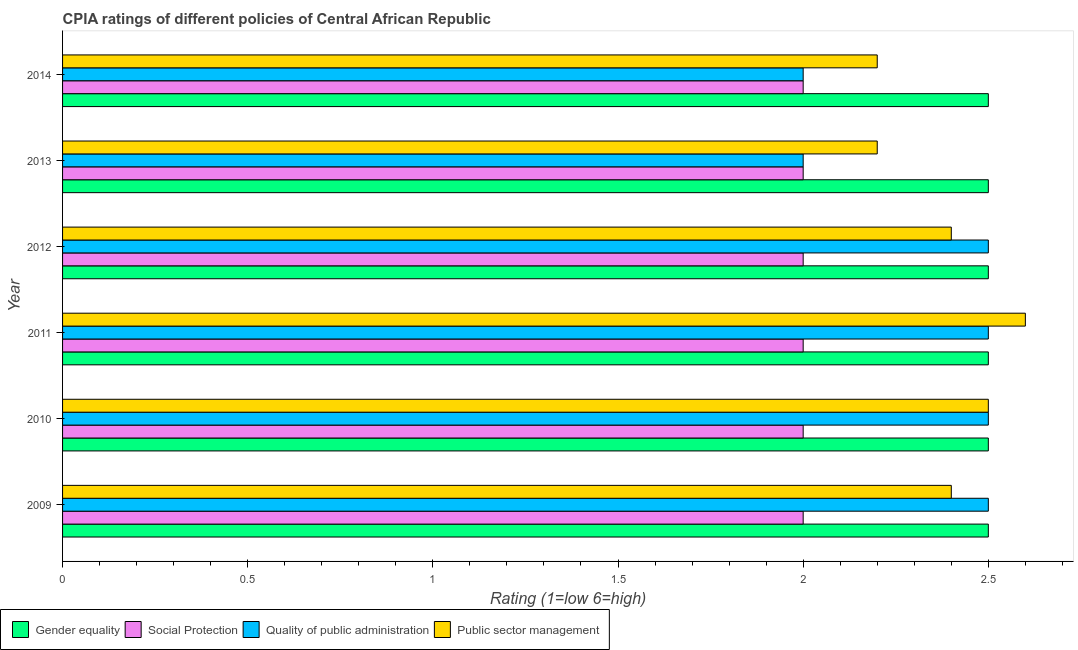Are the number of bars per tick equal to the number of legend labels?
Your answer should be compact. Yes. Are the number of bars on each tick of the Y-axis equal?
Your response must be concise. Yes. How many bars are there on the 3rd tick from the top?
Make the answer very short. 4. What is the label of the 4th group of bars from the top?
Your response must be concise. 2011. Across all years, what is the maximum cpia rating of social protection?
Make the answer very short. 2. In which year was the cpia rating of public sector management minimum?
Your response must be concise. 2013. What is the total cpia rating of social protection in the graph?
Your answer should be very brief. 12. What is the difference between the cpia rating of public sector management in 2013 and that in 2014?
Ensure brevity in your answer.  0. What is the average cpia rating of social protection per year?
Your response must be concise. 2. In the year 2009, what is the difference between the cpia rating of gender equality and cpia rating of quality of public administration?
Keep it short and to the point. 0. What is the ratio of the cpia rating of quality of public administration in 2009 to that in 2014?
Make the answer very short. 1.25. What is the difference between the highest and the second highest cpia rating of public sector management?
Offer a terse response. 0.1. What is the difference between the highest and the lowest cpia rating of gender equality?
Keep it short and to the point. 0. Is the sum of the cpia rating of social protection in 2009 and 2014 greater than the maximum cpia rating of gender equality across all years?
Make the answer very short. Yes. Is it the case that in every year, the sum of the cpia rating of social protection and cpia rating of quality of public administration is greater than the sum of cpia rating of public sector management and cpia rating of gender equality?
Offer a very short reply. No. What does the 3rd bar from the top in 2009 represents?
Give a very brief answer. Social Protection. What does the 2nd bar from the bottom in 2009 represents?
Offer a terse response. Social Protection. How many bars are there?
Keep it short and to the point. 24. Are all the bars in the graph horizontal?
Your answer should be compact. Yes. How many years are there in the graph?
Provide a short and direct response. 6. Are the values on the major ticks of X-axis written in scientific E-notation?
Offer a very short reply. No. Does the graph contain any zero values?
Make the answer very short. No. Does the graph contain grids?
Your answer should be very brief. No. What is the title of the graph?
Your answer should be very brief. CPIA ratings of different policies of Central African Republic. Does "Quality of public administration" appear as one of the legend labels in the graph?
Offer a very short reply. Yes. What is the Rating (1=low 6=high) of Gender equality in 2009?
Give a very brief answer. 2.5. What is the Rating (1=low 6=high) of Social Protection in 2009?
Your answer should be very brief. 2. What is the Rating (1=low 6=high) of Quality of public administration in 2009?
Make the answer very short. 2.5. What is the Rating (1=low 6=high) in Public sector management in 2009?
Provide a short and direct response. 2.4. What is the Rating (1=low 6=high) in Gender equality in 2010?
Offer a very short reply. 2.5. What is the Rating (1=low 6=high) of Social Protection in 2010?
Give a very brief answer. 2. What is the Rating (1=low 6=high) of Gender equality in 2011?
Make the answer very short. 2.5. What is the Rating (1=low 6=high) of Quality of public administration in 2011?
Give a very brief answer. 2.5. What is the Rating (1=low 6=high) in Public sector management in 2011?
Ensure brevity in your answer.  2.6. What is the Rating (1=low 6=high) of Social Protection in 2012?
Give a very brief answer. 2. What is the Rating (1=low 6=high) in Quality of public administration in 2012?
Your answer should be compact. 2.5. What is the Rating (1=low 6=high) in Gender equality in 2013?
Give a very brief answer. 2.5. What is the Rating (1=low 6=high) in Social Protection in 2013?
Your answer should be very brief. 2. What is the Rating (1=low 6=high) in Quality of public administration in 2013?
Give a very brief answer. 2. What is the Rating (1=low 6=high) in Social Protection in 2014?
Your answer should be compact. 2. Across all years, what is the minimum Rating (1=low 6=high) of Social Protection?
Offer a very short reply. 2. What is the total Rating (1=low 6=high) of Gender equality in the graph?
Offer a very short reply. 15. What is the total Rating (1=low 6=high) of Social Protection in the graph?
Offer a very short reply. 12. What is the total Rating (1=low 6=high) of Quality of public administration in the graph?
Keep it short and to the point. 14. What is the total Rating (1=low 6=high) in Public sector management in the graph?
Ensure brevity in your answer.  14.3. What is the difference between the Rating (1=low 6=high) of Gender equality in 2009 and that in 2010?
Your response must be concise. 0. What is the difference between the Rating (1=low 6=high) in Public sector management in 2009 and that in 2010?
Offer a terse response. -0.1. What is the difference between the Rating (1=low 6=high) of Social Protection in 2009 and that in 2011?
Ensure brevity in your answer.  0. What is the difference between the Rating (1=low 6=high) in Public sector management in 2009 and that in 2011?
Offer a very short reply. -0.2. What is the difference between the Rating (1=low 6=high) in Gender equality in 2009 and that in 2012?
Make the answer very short. 0. What is the difference between the Rating (1=low 6=high) in Social Protection in 2009 and that in 2012?
Your answer should be very brief. 0. What is the difference between the Rating (1=low 6=high) of Quality of public administration in 2009 and that in 2012?
Your answer should be compact. 0. What is the difference between the Rating (1=low 6=high) in Public sector management in 2009 and that in 2012?
Your answer should be compact. 0. What is the difference between the Rating (1=low 6=high) in Social Protection in 2009 and that in 2013?
Your answer should be very brief. 0. What is the difference between the Rating (1=low 6=high) of Quality of public administration in 2009 and that in 2013?
Keep it short and to the point. 0.5. What is the difference between the Rating (1=low 6=high) of Quality of public administration in 2009 and that in 2014?
Your response must be concise. 0.5. What is the difference between the Rating (1=low 6=high) in Gender equality in 2010 and that in 2011?
Offer a terse response. 0. What is the difference between the Rating (1=low 6=high) in Social Protection in 2010 and that in 2011?
Your response must be concise. 0. What is the difference between the Rating (1=low 6=high) of Public sector management in 2010 and that in 2011?
Give a very brief answer. -0.1. What is the difference between the Rating (1=low 6=high) in Gender equality in 2010 and that in 2013?
Your response must be concise. 0. What is the difference between the Rating (1=low 6=high) of Social Protection in 2010 and that in 2013?
Your answer should be very brief. 0. What is the difference between the Rating (1=low 6=high) of Gender equality in 2010 and that in 2014?
Your response must be concise. 0. What is the difference between the Rating (1=low 6=high) of Public sector management in 2010 and that in 2014?
Your response must be concise. 0.3. What is the difference between the Rating (1=low 6=high) in Social Protection in 2011 and that in 2012?
Your answer should be very brief. 0. What is the difference between the Rating (1=low 6=high) in Gender equality in 2011 and that in 2013?
Your answer should be compact. 0. What is the difference between the Rating (1=low 6=high) in Quality of public administration in 2011 and that in 2013?
Make the answer very short. 0.5. What is the difference between the Rating (1=low 6=high) of Public sector management in 2011 and that in 2013?
Provide a short and direct response. 0.4. What is the difference between the Rating (1=low 6=high) in Gender equality in 2011 and that in 2014?
Provide a short and direct response. 0. What is the difference between the Rating (1=low 6=high) of Social Protection in 2011 and that in 2014?
Keep it short and to the point. 0. What is the difference between the Rating (1=low 6=high) of Quality of public administration in 2011 and that in 2014?
Your answer should be very brief. 0.5. What is the difference between the Rating (1=low 6=high) of Gender equality in 2012 and that in 2013?
Your answer should be very brief. 0. What is the difference between the Rating (1=low 6=high) in Quality of public administration in 2012 and that in 2013?
Give a very brief answer. 0.5. What is the difference between the Rating (1=low 6=high) of Social Protection in 2012 and that in 2014?
Provide a succinct answer. 0. What is the difference between the Rating (1=low 6=high) of Quality of public administration in 2012 and that in 2014?
Ensure brevity in your answer.  0.5. What is the difference between the Rating (1=low 6=high) of Gender equality in 2013 and that in 2014?
Ensure brevity in your answer.  0. What is the difference between the Rating (1=low 6=high) in Quality of public administration in 2013 and that in 2014?
Provide a short and direct response. 0. What is the difference between the Rating (1=low 6=high) in Public sector management in 2013 and that in 2014?
Provide a short and direct response. 0. What is the difference between the Rating (1=low 6=high) of Gender equality in 2009 and the Rating (1=low 6=high) of Social Protection in 2010?
Provide a succinct answer. 0.5. What is the difference between the Rating (1=low 6=high) in Gender equality in 2009 and the Rating (1=low 6=high) in Quality of public administration in 2010?
Make the answer very short. 0. What is the difference between the Rating (1=low 6=high) of Gender equality in 2009 and the Rating (1=low 6=high) of Public sector management in 2010?
Offer a terse response. 0. What is the difference between the Rating (1=low 6=high) of Gender equality in 2009 and the Rating (1=low 6=high) of Quality of public administration in 2011?
Keep it short and to the point. 0. What is the difference between the Rating (1=low 6=high) in Social Protection in 2009 and the Rating (1=low 6=high) in Public sector management in 2011?
Keep it short and to the point. -0.6. What is the difference between the Rating (1=low 6=high) of Quality of public administration in 2009 and the Rating (1=low 6=high) of Public sector management in 2011?
Make the answer very short. -0.1. What is the difference between the Rating (1=low 6=high) in Social Protection in 2009 and the Rating (1=low 6=high) in Public sector management in 2012?
Offer a very short reply. -0.4. What is the difference between the Rating (1=low 6=high) in Gender equality in 2009 and the Rating (1=low 6=high) in Quality of public administration in 2013?
Keep it short and to the point. 0.5. What is the difference between the Rating (1=low 6=high) in Gender equality in 2009 and the Rating (1=low 6=high) in Public sector management in 2013?
Offer a very short reply. 0.3. What is the difference between the Rating (1=low 6=high) in Gender equality in 2009 and the Rating (1=low 6=high) in Quality of public administration in 2014?
Your response must be concise. 0.5. What is the difference between the Rating (1=low 6=high) in Gender equality in 2010 and the Rating (1=low 6=high) in Public sector management in 2011?
Ensure brevity in your answer.  -0.1. What is the difference between the Rating (1=low 6=high) in Social Protection in 2010 and the Rating (1=low 6=high) in Quality of public administration in 2011?
Your response must be concise. -0.5. What is the difference between the Rating (1=low 6=high) of Social Protection in 2010 and the Rating (1=low 6=high) of Public sector management in 2011?
Your response must be concise. -0.6. What is the difference between the Rating (1=low 6=high) in Quality of public administration in 2010 and the Rating (1=low 6=high) in Public sector management in 2011?
Your answer should be very brief. -0.1. What is the difference between the Rating (1=low 6=high) of Social Protection in 2010 and the Rating (1=low 6=high) of Quality of public administration in 2012?
Your answer should be compact. -0.5. What is the difference between the Rating (1=low 6=high) in Quality of public administration in 2010 and the Rating (1=low 6=high) in Public sector management in 2012?
Make the answer very short. 0.1. What is the difference between the Rating (1=low 6=high) in Gender equality in 2010 and the Rating (1=low 6=high) in Public sector management in 2013?
Provide a succinct answer. 0.3. What is the difference between the Rating (1=low 6=high) in Quality of public administration in 2010 and the Rating (1=low 6=high) in Public sector management in 2013?
Offer a terse response. 0.3. What is the difference between the Rating (1=low 6=high) of Social Protection in 2010 and the Rating (1=low 6=high) of Public sector management in 2014?
Offer a very short reply. -0.2. What is the difference between the Rating (1=low 6=high) of Gender equality in 2011 and the Rating (1=low 6=high) of Quality of public administration in 2012?
Your answer should be compact. 0. What is the difference between the Rating (1=low 6=high) in Gender equality in 2011 and the Rating (1=low 6=high) in Public sector management in 2012?
Keep it short and to the point. 0.1. What is the difference between the Rating (1=low 6=high) in Social Protection in 2011 and the Rating (1=low 6=high) in Quality of public administration in 2012?
Your answer should be very brief. -0.5. What is the difference between the Rating (1=low 6=high) in Social Protection in 2011 and the Rating (1=low 6=high) in Public sector management in 2012?
Provide a succinct answer. -0.4. What is the difference between the Rating (1=low 6=high) of Gender equality in 2011 and the Rating (1=low 6=high) of Quality of public administration in 2013?
Offer a terse response. 0.5. What is the difference between the Rating (1=low 6=high) of Gender equality in 2011 and the Rating (1=low 6=high) of Public sector management in 2013?
Make the answer very short. 0.3. What is the difference between the Rating (1=low 6=high) of Social Protection in 2011 and the Rating (1=low 6=high) of Public sector management in 2013?
Your response must be concise. -0.2. What is the difference between the Rating (1=low 6=high) in Social Protection in 2011 and the Rating (1=low 6=high) in Quality of public administration in 2014?
Provide a succinct answer. 0. What is the difference between the Rating (1=low 6=high) in Social Protection in 2011 and the Rating (1=low 6=high) in Public sector management in 2014?
Keep it short and to the point. -0.2. What is the difference between the Rating (1=low 6=high) of Gender equality in 2012 and the Rating (1=low 6=high) of Quality of public administration in 2013?
Provide a short and direct response. 0.5. What is the difference between the Rating (1=low 6=high) of Gender equality in 2012 and the Rating (1=low 6=high) of Public sector management in 2013?
Provide a succinct answer. 0.3. What is the difference between the Rating (1=low 6=high) in Social Protection in 2012 and the Rating (1=low 6=high) in Quality of public administration in 2013?
Ensure brevity in your answer.  0. What is the difference between the Rating (1=low 6=high) of Quality of public administration in 2012 and the Rating (1=low 6=high) of Public sector management in 2013?
Offer a very short reply. 0.3. What is the difference between the Rating (1=low 6=high) in Gender equality in 2012 and the Rating (1=low 6=high) in Quality of public administration in 2014?
Provide a succinct answer. 0.5. What is the difference between the Rating (1=low 6=high) of Gender equality in 2012 and the Rating (1=low 6=high) of Public sector management in 2014?
Provide a succinct answer. 0.3. What is the difference between the Rating (1=low 6=high) in Social Protection in 2012 and the Rating (1=low 6=high) in Public sector management in 2014?
Your response must be concise. -0.2. What is the difference between the Rating (1=low 6=high) of Quality of public administration in 2012 and the Rating (1=low 6=high) of Public sector management in 2014?
Your response must be concise. 0.3. What is the difference between the Rating (1=low 6=high) of Gender equality in 2013 and the Rating (1=low 6=high) of Quality of public administration in 2014?
Ensure brevity in your answer.  0.5. What is the difference between the Rating (1=low 6=high) of Social Protection in 2013 and the Rating (1=low 6=high) of Quality of public administration in 2014?
Your response must be concise. 0. What is the average Rating (1=low 6=high) in Gender equality per year?
Provide a succinct answer. 2.5. What is the average Rating (1=low 6=high) of Social Protection per year?
Your answer should be very brief. 2. What is the average Rating (1=low 6=high) in Quality of public administration per year?
Provide a succinct answer. 2.33. What is the average Rating (1=low 6=high) of Public sector management per year?
Offer a very short reply. 2.38. In the year 2009, what is the difference between the Rating (1=low 6=high) in Gender equality and Rating (1=low 6=high) in Social Protection?
Provide a succinct answer. 0.5. In the year 2009, what is the difference between the Rating (1=low 6=high) of Gender equality and Rating (1=low 6=high) of Quality of public administration?
Your answer should be very brief. 0. In the year 2009, what is the difference between the Rating (1=low 6=high) in Social Protection and Rating (1=low 6=high) in Quality of public administration?
Provide a succinct answer. -0.5. In the year 2010, what is the difference between the Rating (1=low 6=high) of Gender equality and Rating (1=low 6=high) of Public sector management?
Your answer should be very brief. 0. In the year 2010, what is the difference between the Rating (1=low 6=high) of Social Protection and Rating (1=low 6=high) of Quality of public administration?
Provide a short and direct response. -0.5. In the year 2010, what is the difference between the Rating (1=low 6=high) of Quality of public administration and Rating (1=low 6=high) of Public sector management?
Ensure brevity in your answer.  0. In the year 2011, what is the difference between the Rating (1=low 6=high) of Gender equality and Rating (1=low 6=high) of Social Protection?
Make the answer very short. 0.5. In the year 2011, what is the difference between the Rating (1=low 6=high) in Gender equality and Rating (1=low 6=high) in Public sector management?
Your answer should be compact. -0.1. In the year 2011, what is the difference between the Rating (1=low 6=high) of Quality of public administration and Rating (1=low 6=high) of Public sector management?
Give a very brief answer. -0.1. In the year 2012, what is the difference between the Rating (1=low 6=high) in Gender equality and Rating (1=low 6=high) in Social Protection?
Provide a succinct answer. 0.5. In the year 2012, what is the difference between the Rating (1=low 6=high) in Gender equality and Rating (1=low 6=high) in Quality of public administration?
Give a very brief answer. 0. In the year 2012, what is the difference between the Rating (1=low 6=high) in Social Protection and Rating (1=low 6=high) in Quality of public administration?
Offer a terse response. -0.5. In the year 2012, what is the difference between the Rating (1=low 6=high) of Social Protection and Rating (1=low 6=high) of Public sector management?
Your response must be concise. -0.4. In the year 2013, what is the difference between the Rating (1=low 6=high) in Gender equality and Rating (1=low 6=high) in Quality of public administration?
Provide a succinct answer. 0.5. In the year 2013, what is the difference between the Rating (1=low 6=high) in Gender equality and Rating (1=low 6=high) in Public sector management?
Keep it short and to the point. 0.3. In the year 2013, what is the difference between the Rating (1=low 6=high) in Social Protection and Rating (1=low 6=high) in Quality of public administration?
Give a very brief answer. 0. In the year 2014, what is the difference between the Rating (1=low 6=high) in Gender equality and Rating (1=low 6=high) in Social Protection?
Make the answer very short. 0.5. In the year 2014, what is the difference between the Rating (1=low 6=high) in Quality of public administration and Rating (1=low 6=high) in Public sector management?
Your response must be concise. -0.2. What is the ratio of the Rating (1=low 6=high) in Public sector management in 2009 to that in 2010?
Give a very brief answer. 0.96. What is the ratio of the Rating (1=low 6=high) in Gender equality in 2009 to that in 2011?
Provide a succinct answer. 1. What is the ratio of the Rating (1=low 6=high) of Social Protection in 2009 to that in 2011?
Your response must be concise. 1. What is the ratio of the Rating (1=low 6=high) of Quality of public administration in 2009 to that in 2011?
Give a very brief answer. 1. What is the ratio of the Rating (1=low 6=high) in Social Protection in 2009 to that in 2012?
Ensure brevity in your answer.  1. What is the ratio of the Rating (1=low 6=high) of Quality of public administration in 2009 to that in 2012?
Your response must be concise. 1. What is the ratio of the Rating (1=low 6=high) of Gender equality in 2009 to that in 2013?
Keep it short and to the point. 1. What is the ratio of the Rating (1=low 6=high) in Quality of public administration in 2009 to that in 2013?
Make the answer very short. 1.25. What is the ratio of the Rating (1=low 6=high) of Social Protection in 2009 to that in 2014?
Provide a succinct answer. 1. What is the ratio of the Rating (1=low 6=high) of Quality of public administration in 2009 to that in 2014?
Make the answer very short. 1.25. What is the ratio of the Rating (1=low 6=high) in Gender equality in 2010 to that in 2011?
Offer a very short reply. 1. What is the ratio of the Rating (1=low 6=high) in Social Protection in 2010 to that in 2011?
Your answer should be compact. 1. What is the ratio of the Rating (1=low 6=high) of Public sector management in 2010 to that in 2011?
Provide a succinct answer. 0.96. What is the ratio of the Rating (1=low 6=high) of Gender equality in 2010 to that in 2012?
Keep it short and to the point. 1. What is the ratio of the Rating (1=low 6=high) of Social Protection in 2010 to that in 2012?
Offer a very short reply. 1. What is the ratio of the Rating (1=low 6=high) of Public sector management in 2010 to that in 2012?
Offer a terse response. 1.04. What is the ratio of the Rating (1=low 6=high) in Gender equality in 2010 to that in 2013?
Give a very brief answer. 1. What is the ratio of the Rating (1=low 6=high) of Social Protection in 2010 to that in 2013?
Make the answer very short. 1. What is the ratio of the Rating (1=low 6=high) in Quality of public administration in 2010 to that in 2013?
Offer a terse response. 1.25. What is the ratio of the Rating (1=low 6=high) of Public sector management in 2010 to that in 2013?
Ensure brevity in your answer.  1.14. What is the ratio of the Rating (1=low 6=high) in Gender equality in 2010 to that in 2014?
Provide a succinct answer. 1. What is the ratio of the Rating (1=low 6=high) of Quality of public administration in 2010 to that in 2014?
Keep it short and to the point. 1.25. What is the ratio of the Rating (1=low 6=high) of Public sector management in 2010 to that in 2014?
Offer a very short reply. 1.14. What is the ratio of the Rating (1=low 6=high) of Gender equality in 2011 to that in 2012?
Make the answer very short. 1. What is the ratio of the Rating (1=low 6=high) in Gender equality in 2011 to that in 2013?
Keep it short and to the point. 1. What is the ratio of the Rating (1=low 6=high) in Social Protection in 2011 to that in 2013?
Your answer should be compact. 1. What is the ratio of the Rating (1=low 6=high) of Public sector management in 2011 to that in 2013?
Your answer should be very brief. 1.18. What is the ratio of the Rating (1=low 6=high) of Public sector management in 2011 to that in 2014?
Make the answer very short. 1.18. What is the ratio of the Rating (1=low 6=high) in Gender equality in 2012 to that in 2013?
Keep it short and to the point. 1. What is the ratio of the Rating (1=low 6=high) in Quality of public administration in 2012 to that in 2014?
Make the answer very short. 1.25. What is the ratio of the Rating (1=low 6=high) in Public sector management in 2012 to that in 2014?
Your answer should be very brief. 1.09. What is the ratio of the Rating (1=low 6=high) of Social Protection in 2013 to that in 2014?
Offer a very short reply. 1. What is the difference between the highest and the second highest Rating (1=low 6=high) of Social Protection?
Give a very brief answer. 0. What is the difference between the highest and the second highest Rating (1=low 6=high) in Quality of public administration?
Your answer should be very brief. 0. What is the difference between the highest and the lowest Rating (1=low 6=high) in Social Protection?
Provide a short and direct response. 0. What is the difference between the highest and the lowest Rating (1=low 6=high) in Quality of public administration?
Offer a very short reply. 0.5. 